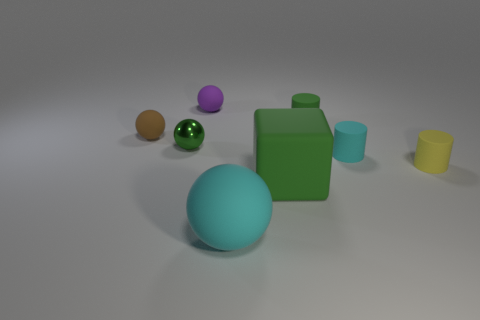Add 1 tiny yellow matte cylinders. How many objects exist? 9 Subtract all cylinders. How many objects are left? 5 Subtract all tiny red blocks. Subtract all tiny matte objects. How many objects are left? 3 Add 5 brown matte objects. How many brown matte objects are left? 6 Add 3 small red metal blocks. How many small red metal blocks exist? 3 Subtract 0 gray balls. How many objects are left? 8 